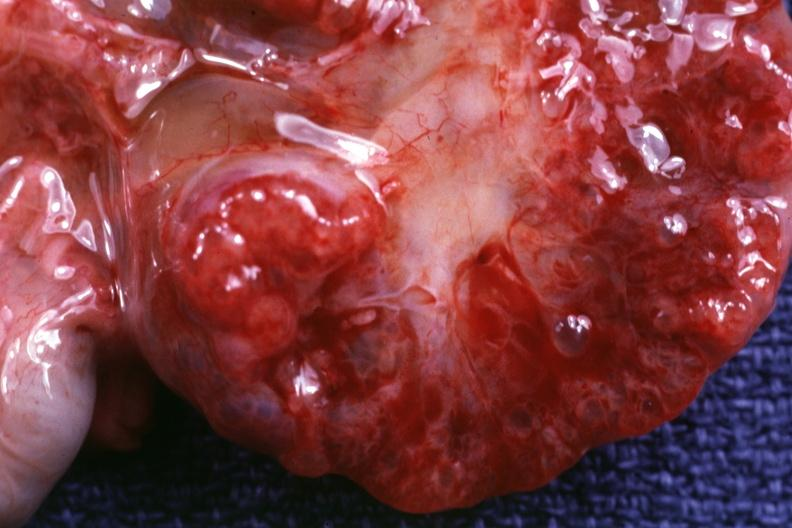s kidney present?
Answer the question using a single word or phrase. Yes 